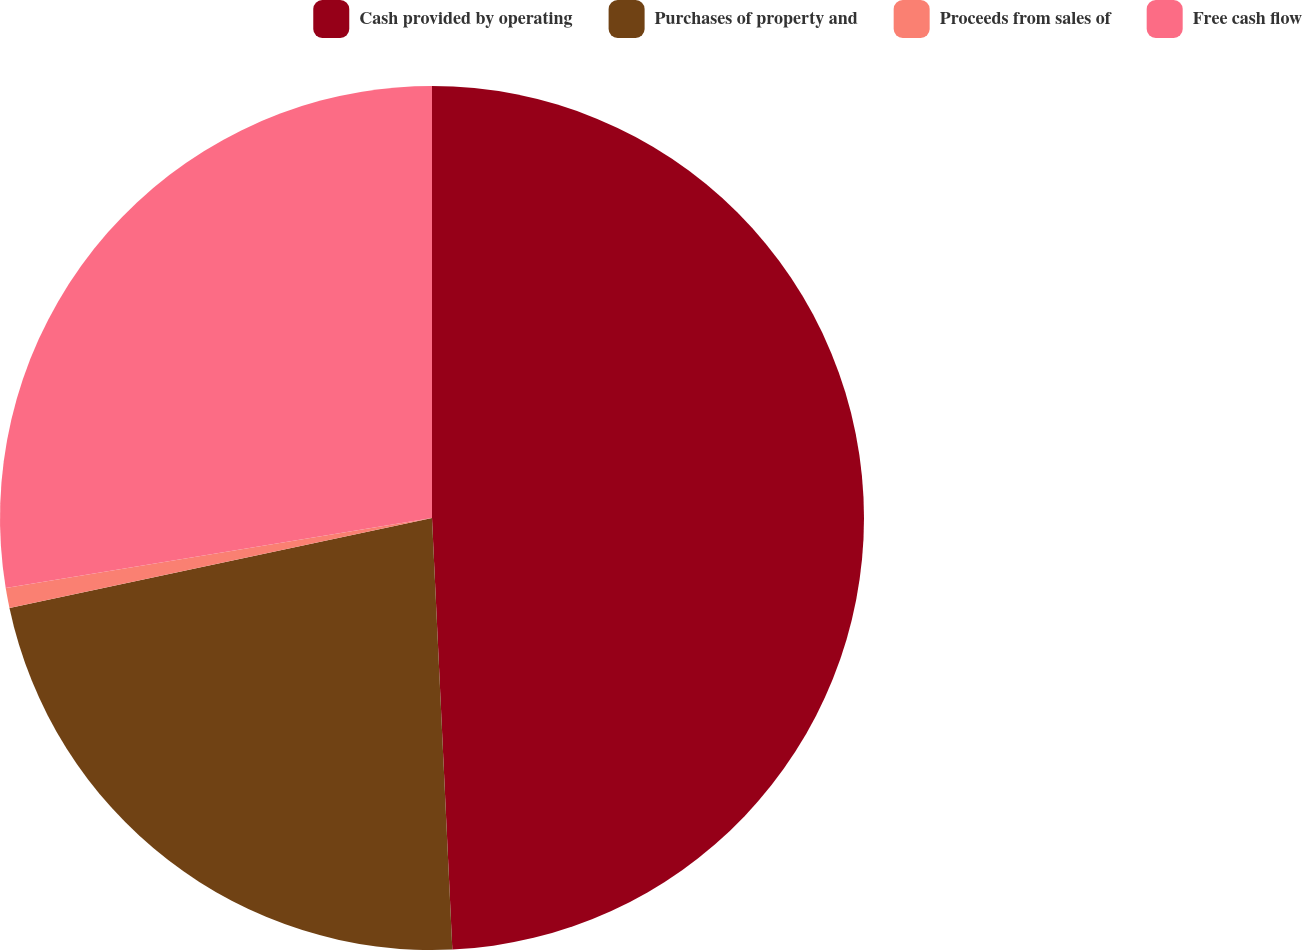Convert chart. <chart><loc_0><loc_0><loc_500><loc_500><pie_chart><fcel>Cash provided by operating<fcel>Purchases of property and<fcel>Proceeds from sales of<fcel>Free cash flow<nl><fcel>49.25%<fcel>22.41%<fcel>0.75%<fcel>27.59%<nl></chart> 